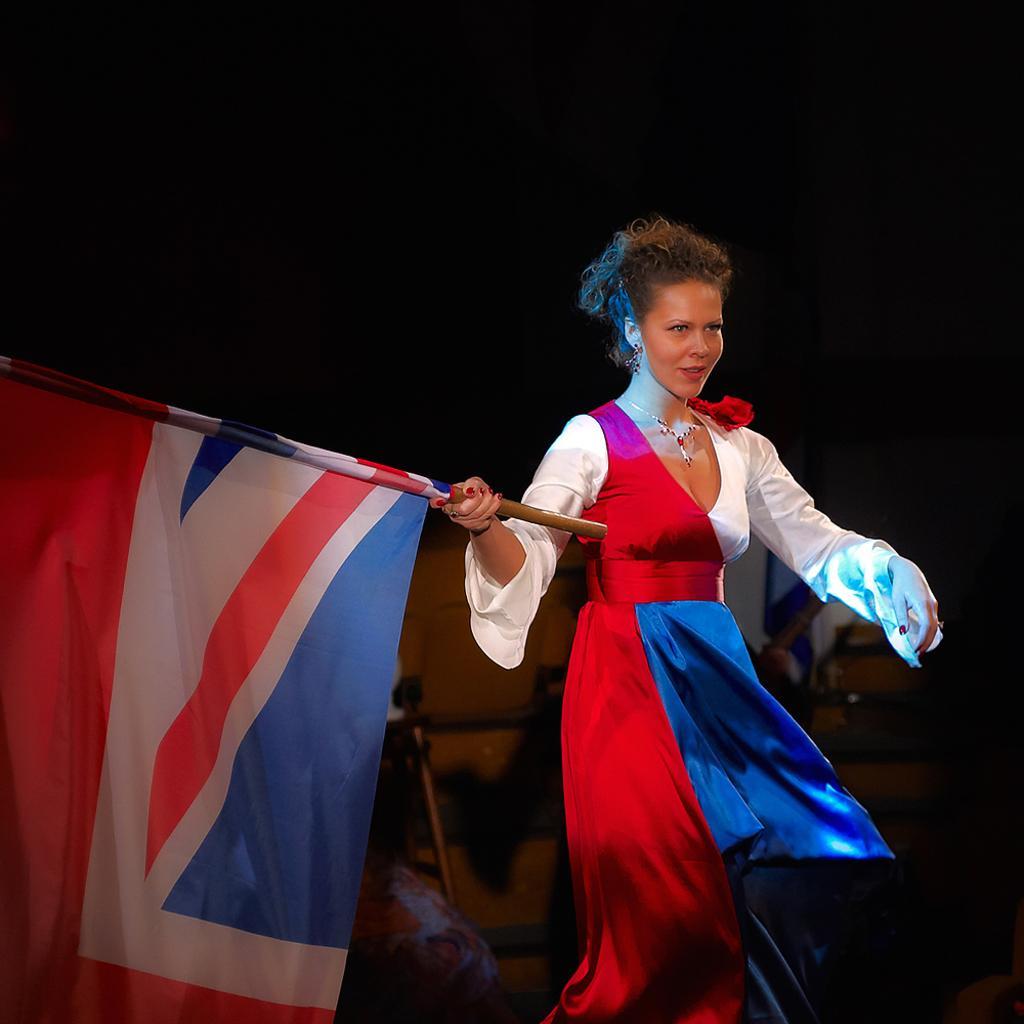Can you describe this image briefly? In this image, we can see a woman is holding a flag with pole. Background we can see blur view. Here we can see few objects. Top of the image, we can see dark view. 